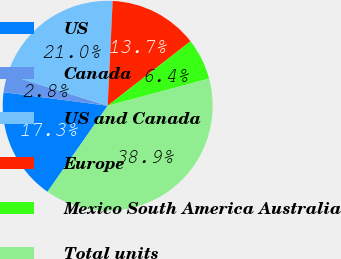<chart> <loc_0><loc_0><loc_500><loc_500><pie_chart><fcel>US<fcel>Canada<fcel>US and Canada<fcel>Europe<fcel>Mexico South America Australia<fcel>Total units<nl><fcel>17.34%<fcel>2.75%<fcel>20.95%<fcel>13.72%<fcel>6.36%<fcel>38.88%<nl></chart> 